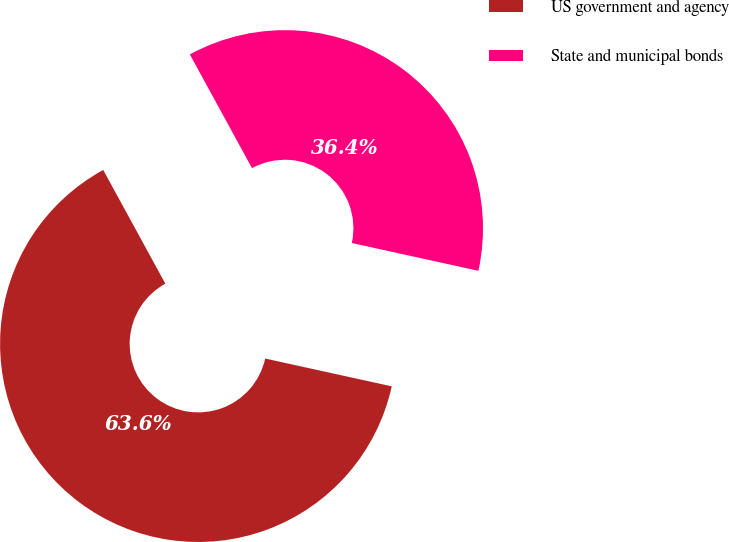<chart> <loc_0><loc_0><loc_500><loc_500><pie_chart><fcel>US government and agency<fcel>State and municipal bonds<nl><fcel>63.6%<fcel>36.4%<nl></chart> 